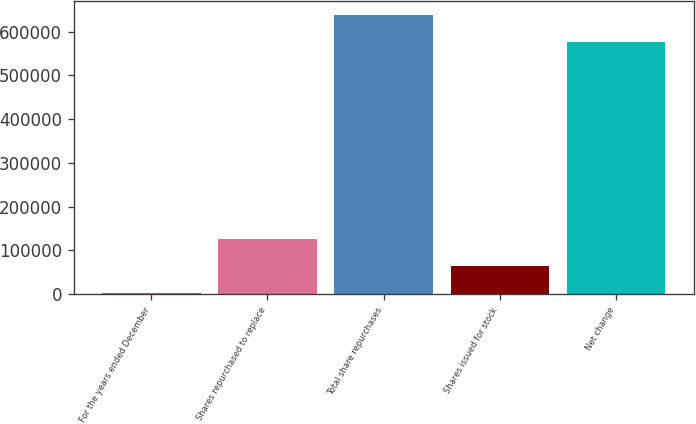Convert chart. <chart><loc_0><loc_0><loc_500><loc_500><bar_chart><fcel>For the years ended December<fcel>Shares repurchased to replace<fcel>Total share repurchases<fcel>Shares issued for stock<fcel>Net change<nl><fcel>2006<fcel>125934<fcel>639048<fcel>63970.2<fcel>577084<nl></chart> 